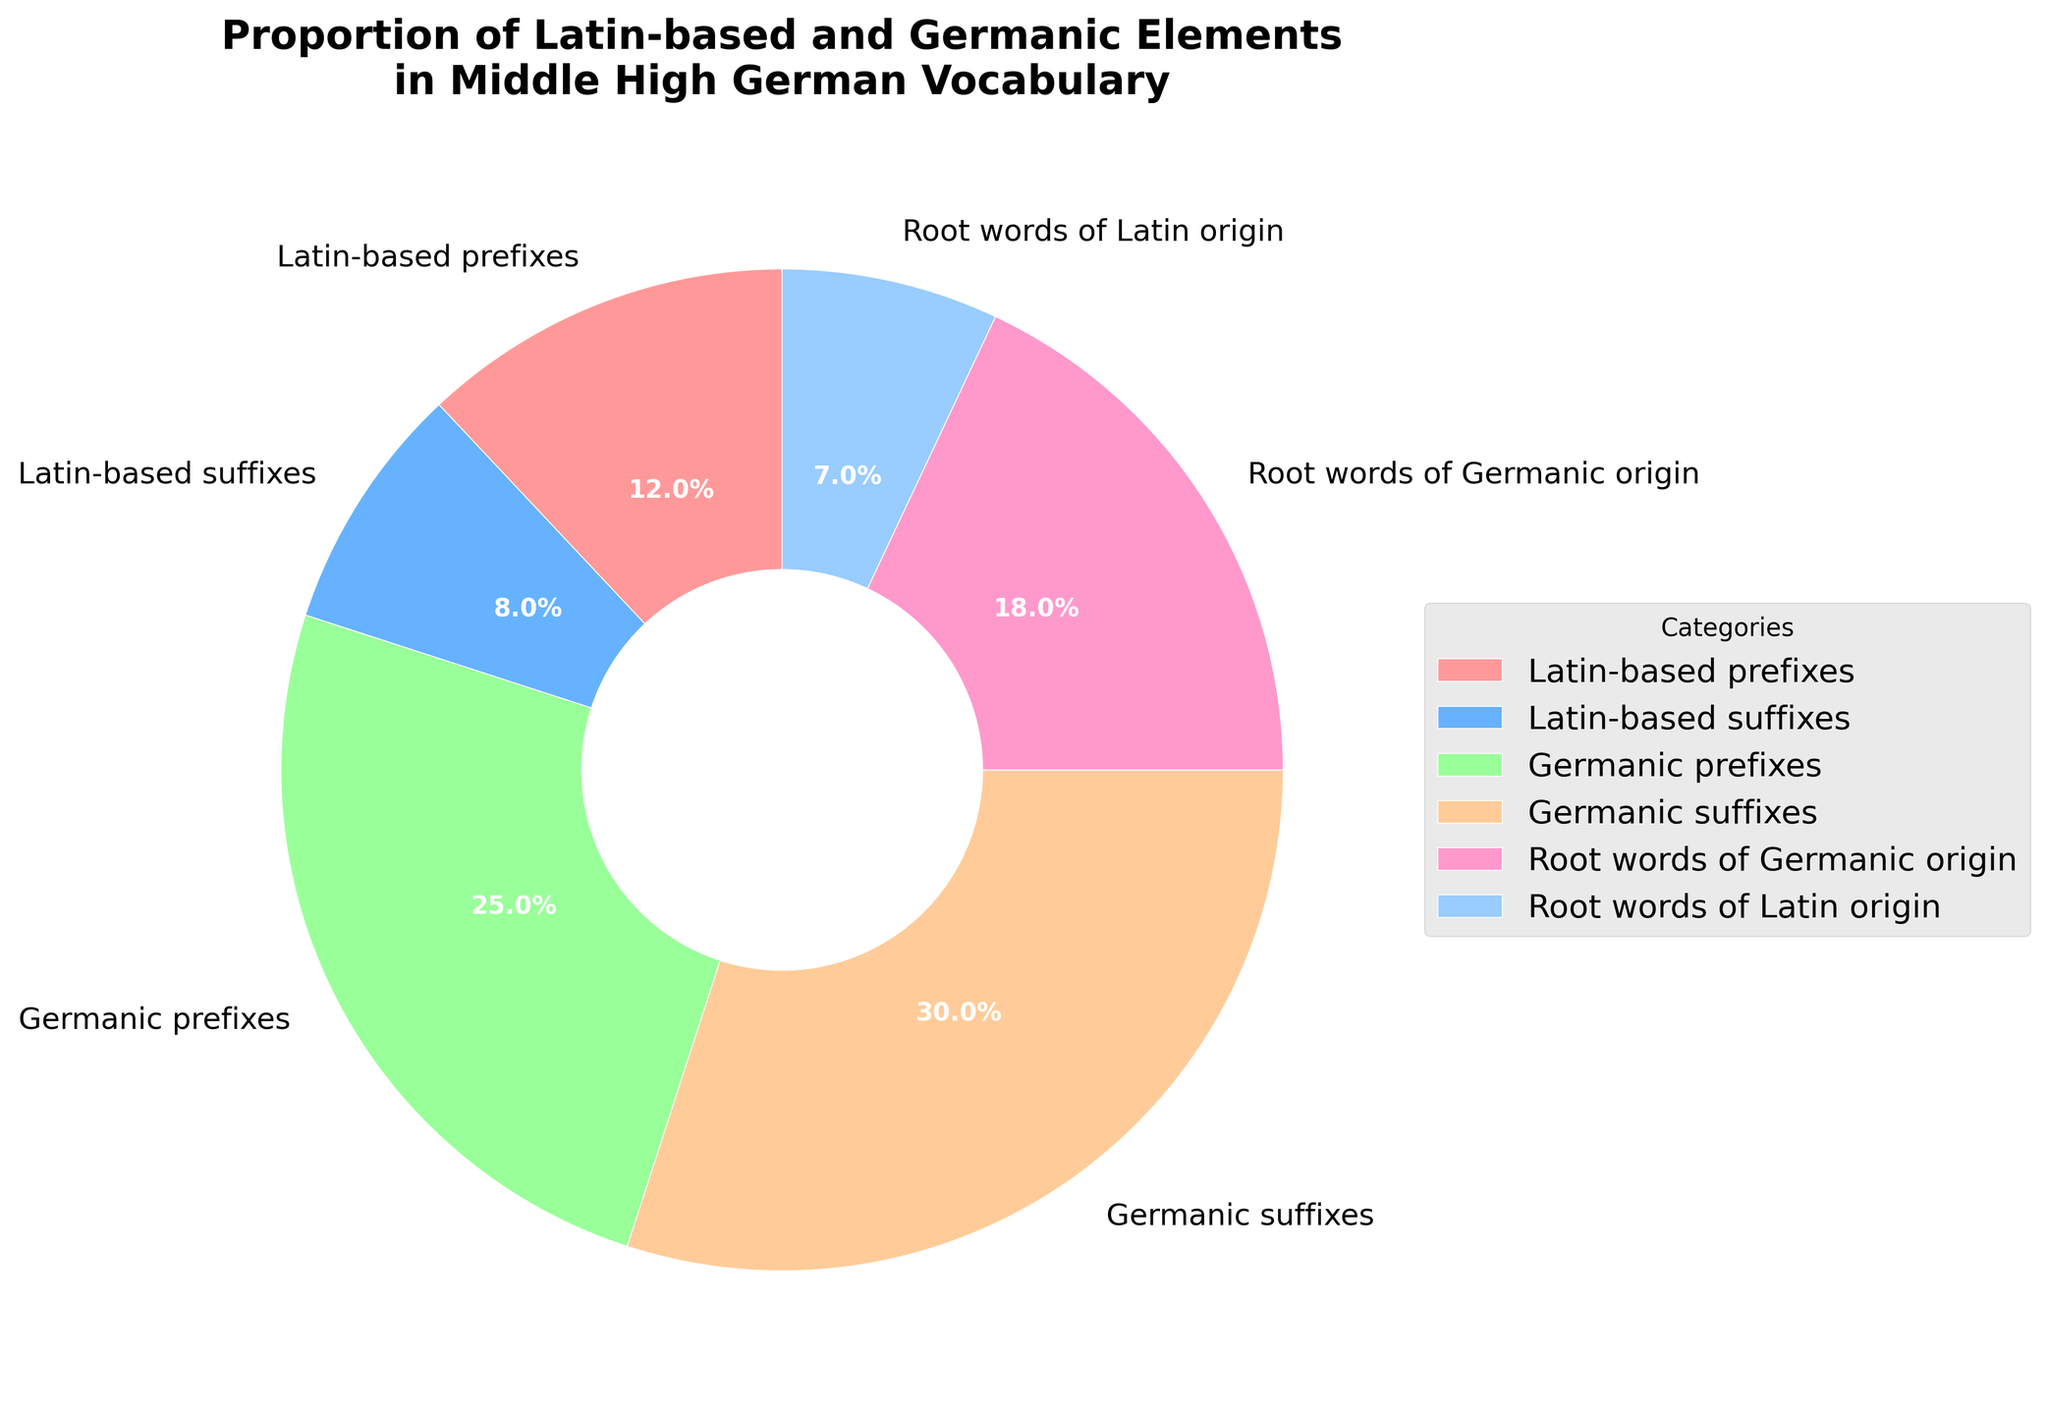what percentage of the vocabulary consists of Latin-based elements? To find the percentage of the vocabulary that consists of Latin-based elements, add the percentages for Latin-based prefixes, Latin-based suffixes, and root words of Latin origin. These values are 12%, 8%, and 7% respectively. Adding them up, 12 + 8 + 7 = 27.
Answer: 27% What is the combined percentage of Germanic prefixes and suffixes? To find the combined percentage of Germanic prefixes and suffixes, add the percentages for Germanic prefixes and Germanic suffixes. These values are 25% and 30% respectively. Adding them up, 25 + 30 = 55.
Answer: 55% Are there more Latin-based prefixes or Germanic root words? Comparing the percentages, Latin-based prefixes make up 12% and root words of Germanic origin make up 18%. Since 18% is greater than 12%, there are more Germanic root words.
Answer: Germanic root words Which category has the lowest percentage, and what is that percentage? Comparing all the categories, the one with the lowest percentage is the root words of Latin origin, comprising 7%. This is the smallest percentage shown in the figure.
Answer: Root words of Latin origin, 7% What is greater: the sum of Latin-based suffixes and root words of Germanic origin, or the percentage of Germanic suffixes? The sum of Latin-based suffixes and root words of Germanic origin is calculated by adding 8% (Latin-based suffixes) and 18% (Germanic root words), resulting in 26%. Germanic suffixes have a percentage of 30%. Since 30% is greater than 26%, the percentage of Germanic suffixes is greater.
Answer: The percentage of Germanic suffixes What percentage of the vocabulary consists of prefixes (both Latin-based and Germanic)? To find the percentage of the vocabulary consisting of prefixes, add the percentages for Latin-based prefixes and Germanic prefixes. These values are 12% and 25% respectively. Adding them up, 12 + 25 = 37.
Answer: 37% How much greater are Germanic suffixes than Latin-based suffixes? To find how much greater Germanic suffixes are than Latin-based suffixes, subtract the percentage of Latin-based suffixes (8%) from the percentage of Germanic suffixes (30%). The difference is 30 - 8 = 22.
Answer: 22% If you combine all Germanic elements (prefixes, suffixes, and root words), what is their total percentage? To find the total percentage of all Germanic elements, add the percentages for Germanic prefixes, Germanic suffixes, and root words of Germanic origin. These values are 25%, 30%, and 18% respectively. Adding them up, 25 + 30 + 18 = 73.
Answer: 73% 